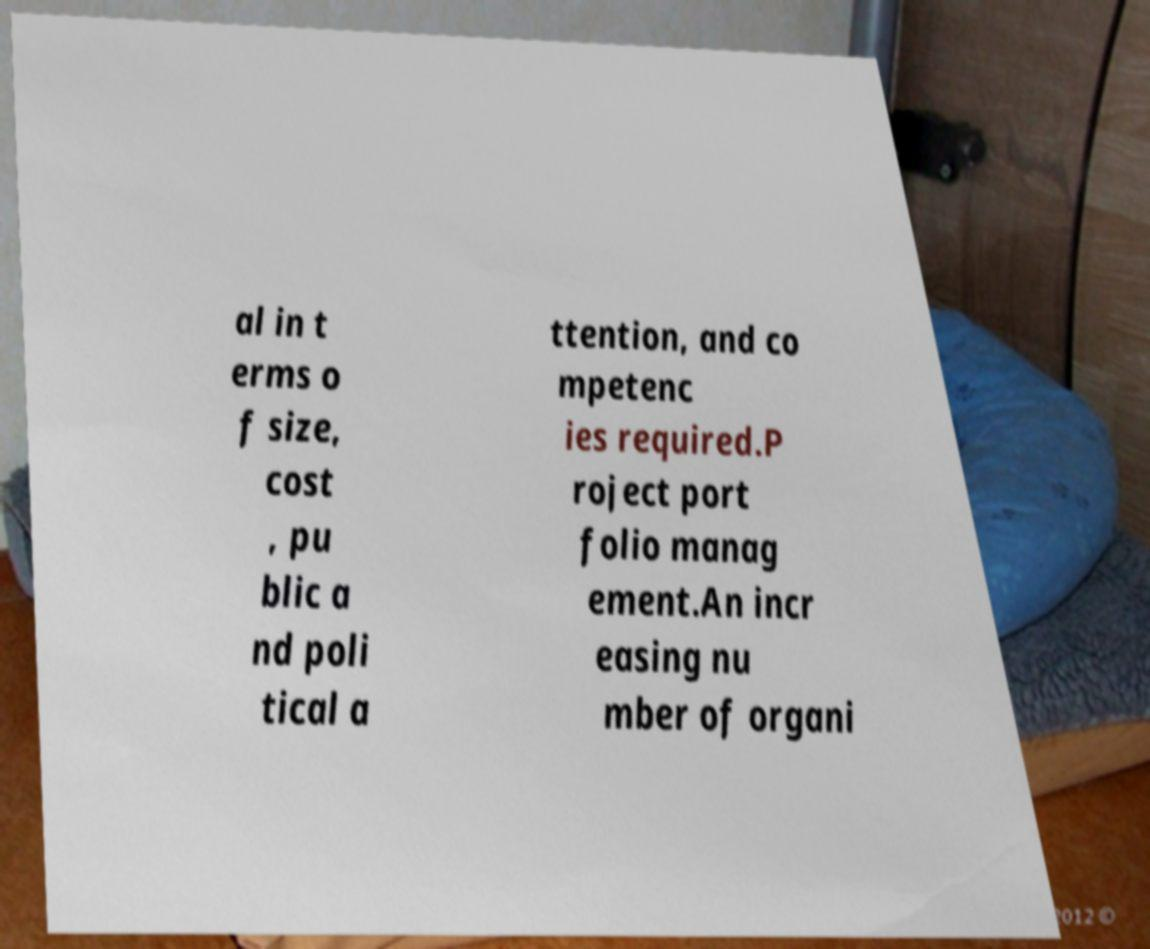For documentation purposes, I need the text within this image transcribed. Could you provide that? al in t erms o f size, cost , pu blic a nd poli tical a ttention, and co mpetenc ies required.P roject port folio manag ement.An incr easing nu mber of organi 